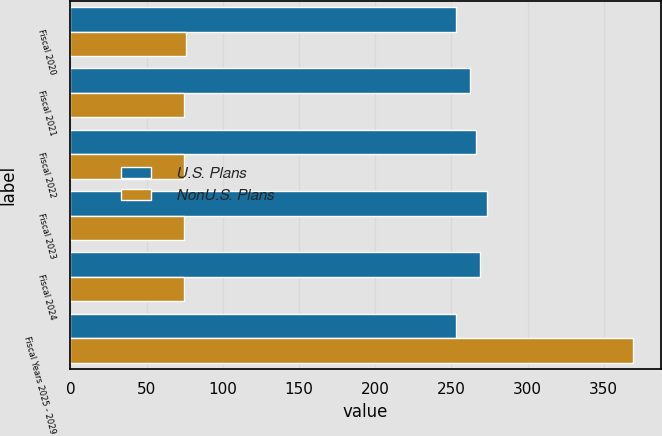<chart> <loc_0><loc_0><loc_500><loc_500><stacked_bar_chart><ecel><fcel>Fiscal 2020<fcel>Fiscal 2021<fcel>Fiscal 2022<fcel>Fiscal 2023<fcel>Fiscal 2024<fcel>Fiscal Years 2025 - 2029<nl><fcel>U.S. Plans<fcel>253.1<fcel>262.3<fcel>266.5<fcel>273.3<fcel>268.8<fcel>253.1<nl><fcel>NonU.S. Plans<fcel>75.9<fcel>74.5<fcel>74.6<fcel>74.8<fcel>74.3<fcel>369<nl></chart> 